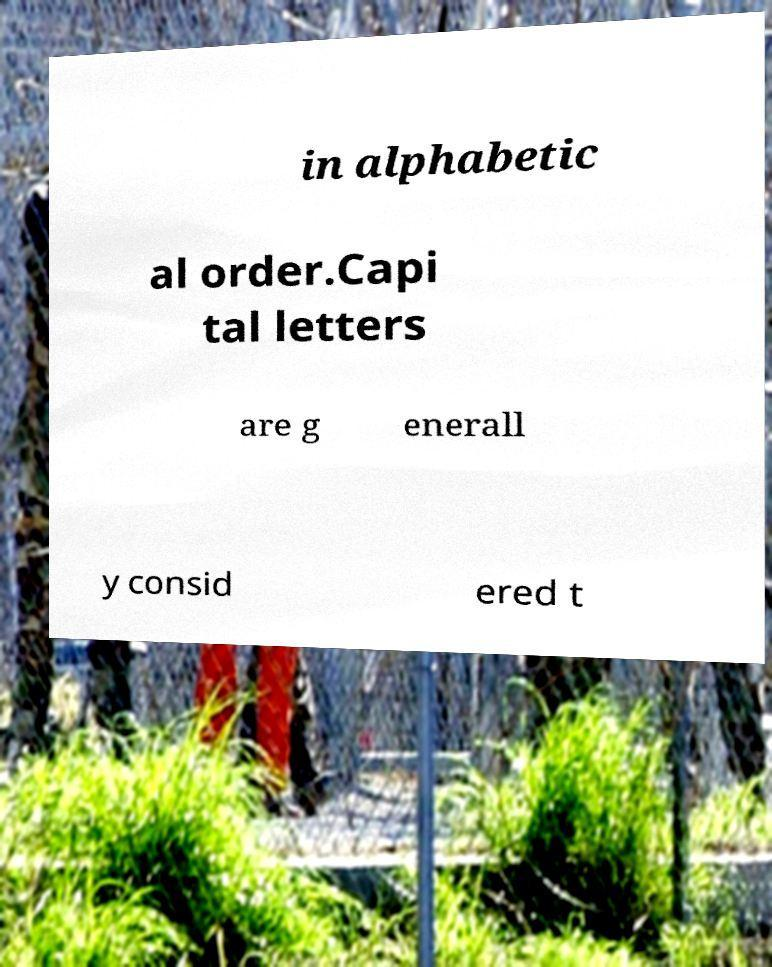Could you extract and type out the text from this image? in alphabetic al order.Capi tal letters are g enerall y consid ered t 